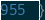<code> <loc_0><loc_0><loc_500><loc_500><_Rust_>}
</code> 